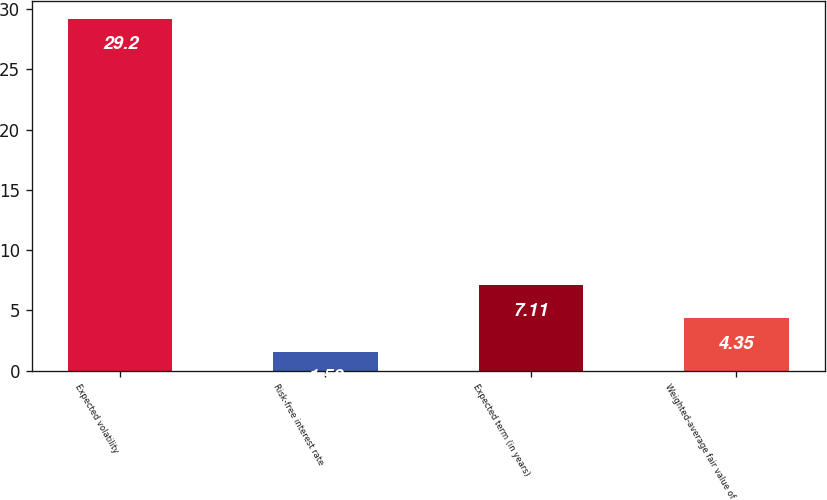Convert chart. <chart><loc_0><loc_0><loc_500><loc_500><bar_chart><fcel>Expected volatility<fcel>Risk-free interest rate<fcel>Expected term (in years)<fcel>Weighted-average fair value of<nl><fcel>29.2<fcel>1.59<fcel>7.11<fcel>4.35<nl></chart> 